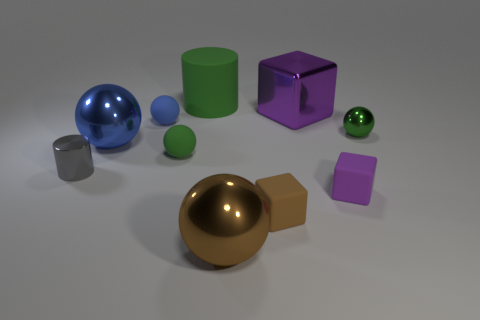Is there another shiny ball of the same color as the tiny metal sphere?
Provide a succinct answer. No. The cylinder that is the same material as the small brown object is what size?
Your answer should be very brief. Large. Are there any other things of the same color as the large matte thing?
Offer a very short reply. Yes. There is a small ball that is on the right side of the large cylinder; what color is it?
Offer a very short reply. Green. Is there a small metal thing that is in front of the large sphere on the left side of the big object in front of the gray cylinder?
Make the answer very short. Yes. Is the number of big things that are left of the large brown thing greater than the number of matte spheres?
Your response must be concise. No. There is a big metal thing behind the green metal object; is its shape the same as the large brown thing?
Provide a succinct answer. No. Are there any other things that have the same material as the tiny blue sphere?
Provide a succinct answer. Yes. What number of objects are purple shiny objects or cylinders behind the tiny gray cylinder?
Keep it short and to the point. 2. There is a thing that is behind the small blue matte ball and in front of the green cylinder; what size is it?
Make the answer very short. Large. 